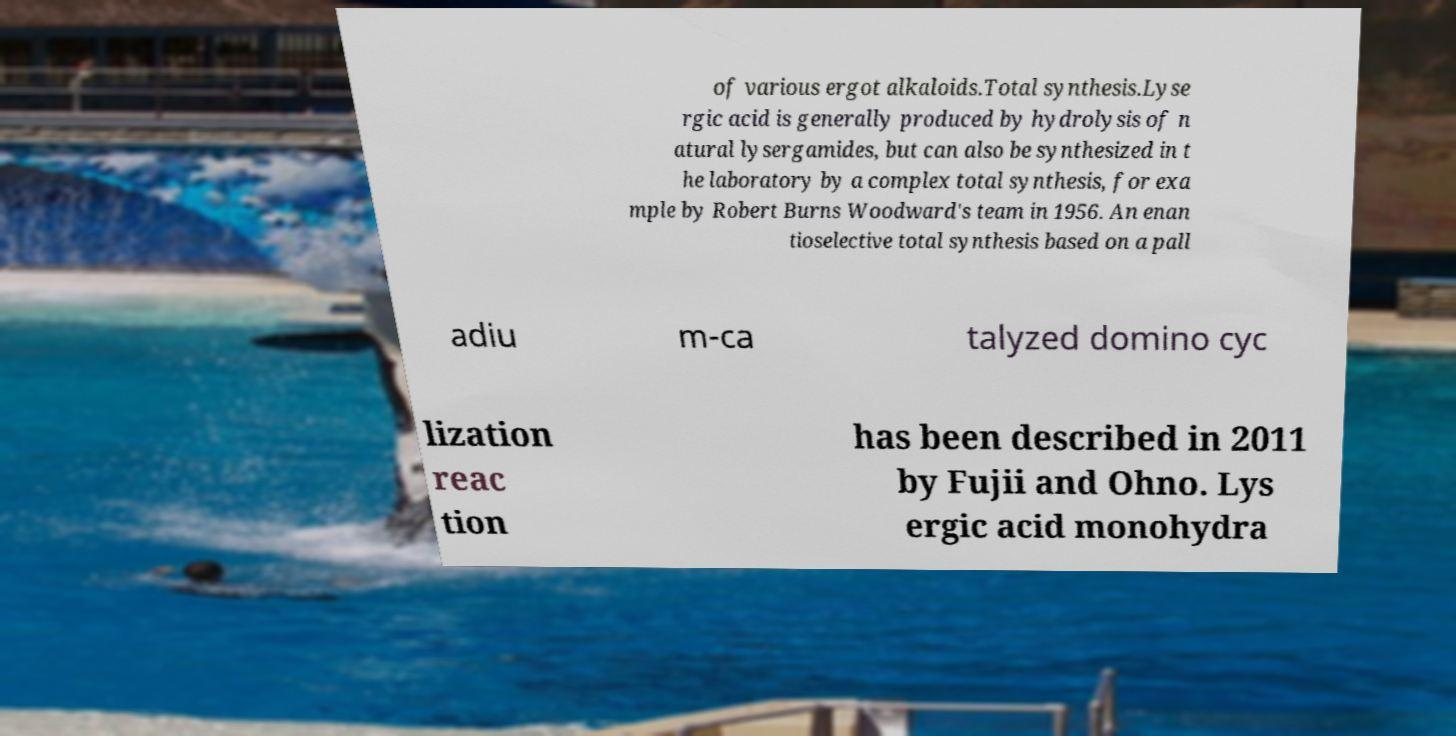There's text embedded in this image that I need extracted. Can you transcribe it verbatim? of various ergot alkaloids.Total synthesis.Lyse rgic acid is generally produced by hydrolysis of n atural lysergamides, but can also be synthesized in t he laboratory by a complex total synthesis, for exa mple by Robert Burns Woodward's team in 1956. An enan tioselective total synthesis based on a pall adiu m-ca talyzed domino cyc lization reac tion has been described in 2011 by Fujii and Ohno. Lys ergic acid monohydra 